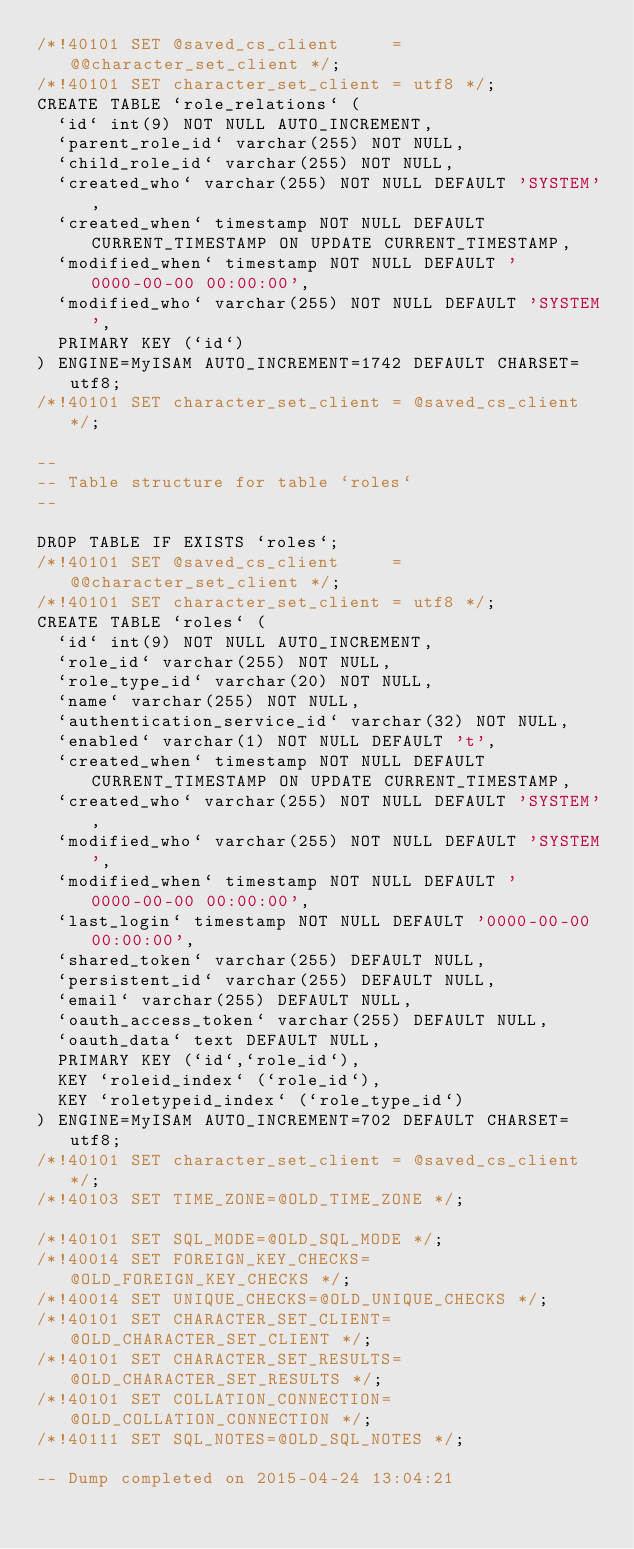<code> <loc_0><loc_0><loc_500><loc_500><_SQL_>/*!40101 SET @saved_cs_client     = @@character_set_client */;
/*!40101 SET character_set_client = utf8 */;
CREATE TABLE `role_relations` (
  `id` int(9) NOT NULL AUTO_INCREMENT,
  `parent_role_id` varchar(255) NOT NULL,
  `child_role_id` varchar(255) NOT NULL,
  `created_who` varchar(255) NOT NULL DEFAULT 'SYSTEM',
  `created_when` timestamp NOT NULL DEFAULT CURRENT_TIMESTAMP ON UPDATE CURRENT_TIMESTAMP,
  `modified_when` timestamp NOT NULL DEFAULT '0000-00-00 00:00:00',
  `modified_who` varchar(255) NOT NULL DEFAULT 'SYSTEM',
  PRIMARY KEY (`id`)
) ENGINE=MyISAM AUTO_INCREMENT=1742 DEFAULT CHARSET=utf8;
/*!40101 SET character_set_client = @saved_cs_client */;

--
-- Table structure for table `roles`
--

DROP TABLE IF EXISTS `roles`;
/*!40101 SET @saved_cs_client     = @@character_set_client */;
/*!40101 SET character_set_client = utf8 */;
CREATE TABLE `roles` (
  `id` int(9) NOT NULL AUTO_INCREMENT,
  `role_id` varchar(255) NOT NULL,
  `role_type_id` varchar(20) NOT NULL,
  `name` varchar(255) NOT NULL,
  `authentication_service_id` varchar(32) NOT NULL,
  `enabled` varchar(1) NOT NULL DEFAULT 't',
  `created_when` timestamp NOT NULL DEFAULT CURRENT_TIMESTAMP ON UPDATE CURRENT_TIMESTAMP,
  `created_who` varchar(255) NOT NULL DEFAULT 'SYSTEM',
  `modified_who` varchar(255) NOT NULL DEFAULT 'SYSTEM',
  `modified_when` timestamp NOT NULL DEFAULT '0000-00-00 00:00:00',
  `last_login` timestamp NOT NULL DEFAULT '0000-00-00 00:00:00',
  `shared_token` varchar(255) DEFAULT NULL,
  `persistent_id` varchar(255) DEFAULT NULL,
  `email` varchar(255) DEFAULT NULL,
  `oauth_access_token` varchar(255) DEFAULT NULL,
  `oauth_data` text DEFAULT NULL,
  PRIMARY KEY (`id`,`role_id`),
  KEY `roleid_index` (`role_id`),
  KEY `roletypeid_index` (`role_type_id`)
) ENGINE=MyISAM AUTO_INCREMENT=702 DEFAULT CHARSET=utf8;
/*!40101 SET character_set_client = @saved_cs_client */;
/*!40103 SET TIME_ZONE=@OLD_TIME_ZONE */;

/*!40101 SET SQL_MODE=@OLD_SQL_MODE */;
/*!40014 SET FOREIGN_KEY_CHECKS=@OLD_FOREIGN_KEY_CHECKS */;
/*!40014 SET UNIQUE_CHECKS=@OLD_UNIQUE_CHECKS */;
/*!40101 SET CHARACTER_SET_CLIENT=@OLD_CHARACTER_SET_CLIENT */;
/*!40101 SET CHARACTER_SET_RESULTS=@OLD_CHARACTER_SET_RESULTS */;
/*!40101 SET COLLATION_CONNECTION=@OLD_COLLATION_CONNECTION */;
/*!40111 SET SQL_NOTES=@OLD_SQL_NOTES */;

-- Dump completed on 2015-04-24 13:04:21
</code> 